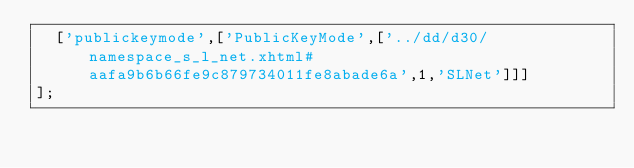<code> <loc_0><loc_0><loc_500><loc_500><_JavaScript_>  ['publickeymode',['PublicKeyMode',['../dd/d30/namespace_s_l_net.xhtml#aafa9b6b66fe9c879734011fe8abade6a',1,'SLNet']]]
];
</code> 